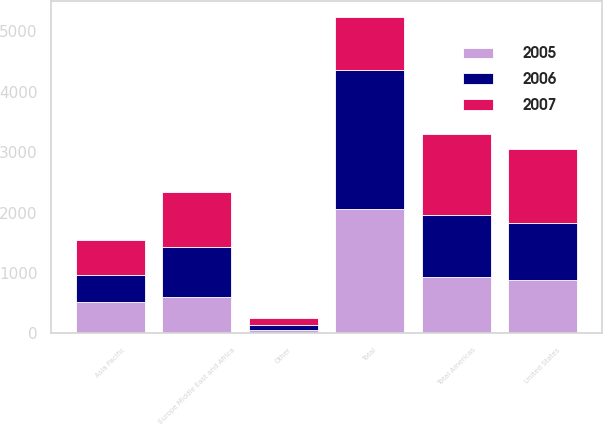Convert chart. <chart><loc_0><loc_0><loc_500><loc_500><stacked_bar_chart><ecel><fcel>United States<fcel>Other<fcel>Total Americas<fcel>Europe Middle East and Africa<fcel>Asia Pacific<fcel>Total<nl><fcel>2007<fcel>1215.8<fcel>124.7<fcel>1340.5<fcel>918<fcel>577.6<fcel>879<nl><fcel>2006<fcel>950.3<fcel>83<fcel>1033.3<fcel>817.4<fcel>452.9<fcel>2303.6<nl><fcel>2005<fcel>879<fcel>53.9<fcel>932.9<fcel>610.1<fcel>521<fcel>2064<nl></chart> 